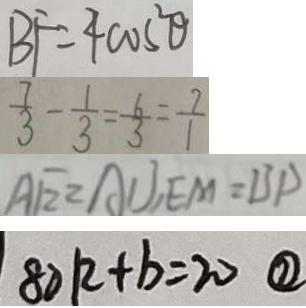Convert formula to latex. <formula><loc_0><loc_0><loc_500><loc_500>B F = 4 \cos ^ { 2 } \theta 
 \frac { 7 } { 3 } - \frac { 1 } { 3 } = \frac { 6 } { 3 } = \frac { 7 } { 1 } 
 A E = A U , E M = B P 
 8 0 k + b = 2 0 \textcircled { 2 }</formula> 